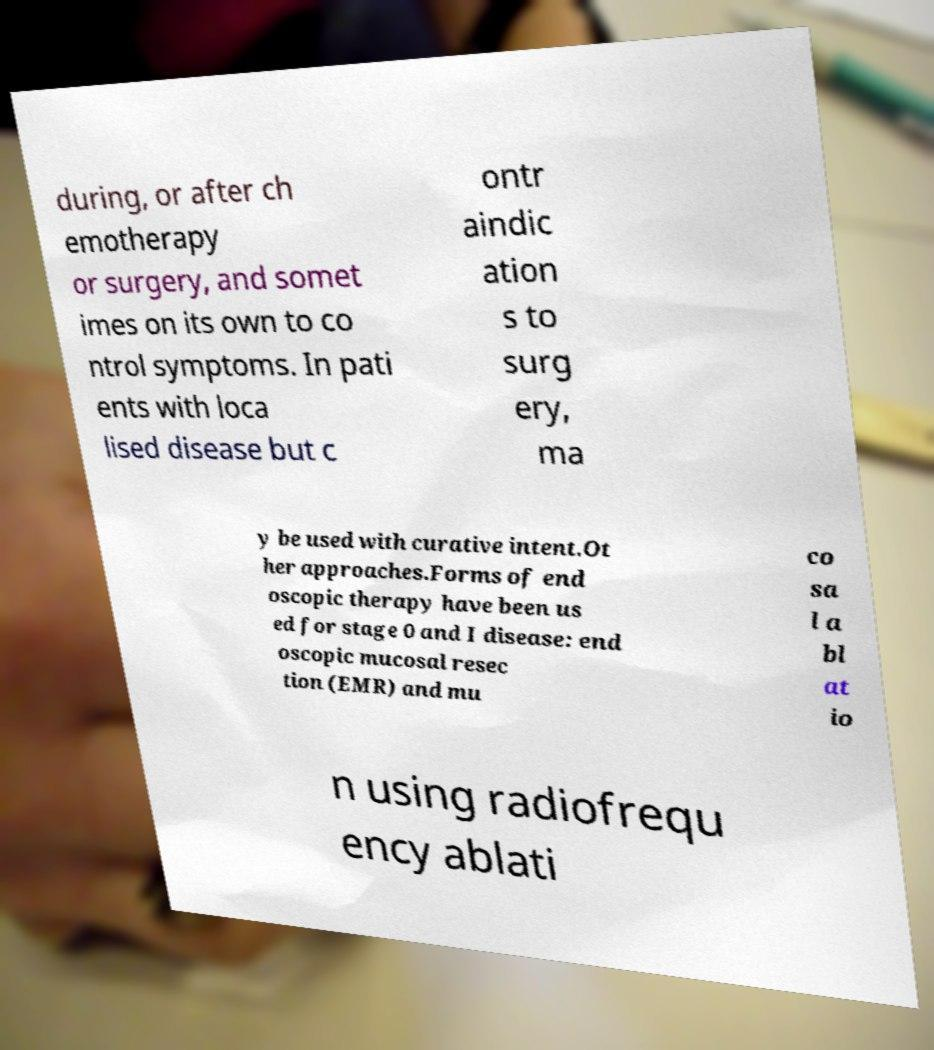Can you read and provide the text displayed in the image?This photo seems to have some interesting text. Can you extract and type it out for me? during, or after ch emotherapy or surgery, and somet imes on its own to co ntrol symptoms. In pati ents with loca lised disease but c ontr aindic ation s to surg ery, ma y be used with curative intent.Ot her approaches.Forms of end oscopic therapy have been us ed for stage 0 and I disease: end oscopic mucosal resec tion (EMR) and mu co sa l a bl at io n using radiofrequ ency ablati 